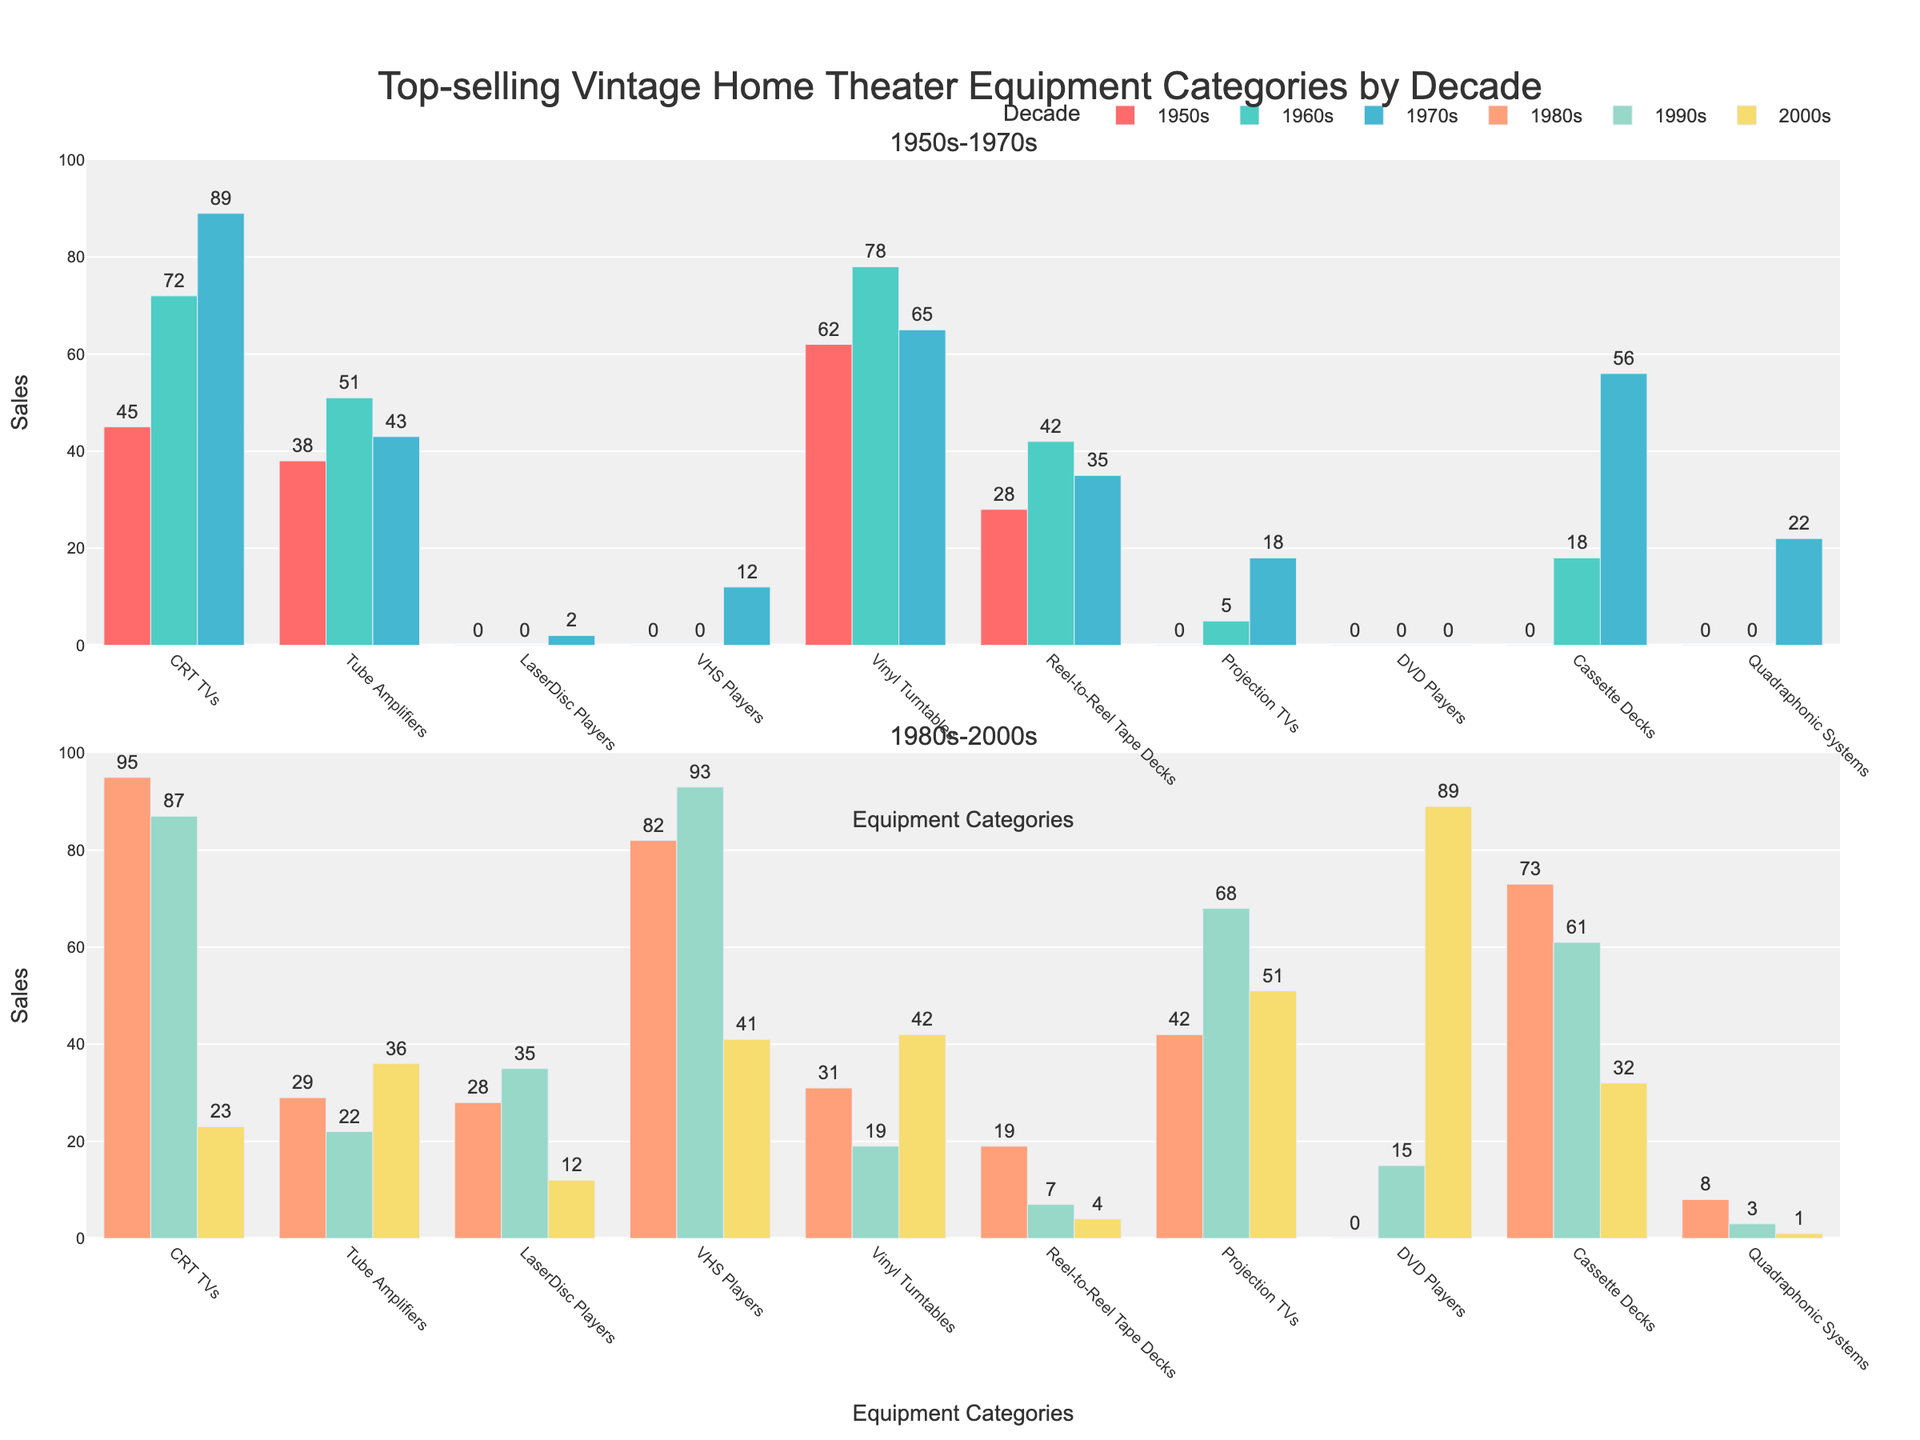What was the highest-selling equipment category in the 1980s? The highest-selling category in the 1980s can be determined by identifying the tallest bar within the 1980s group. The VHS Players bar is the tallest.
Answer: VHS Players Which decade saw the highest sales for DVD Players? The height of the DVD Players bar in each decade can reveal the highest sales. The tallest DVD Players bar appears in the 2000s section.
Answer: 2000s How did the sales of CRT TVs change from the 1950s to the 1990s? By comparing the heights of the CRT TVs bars from the 1950s to the 1990s, we observe that the heights were 45 in 1950s, 72 in 1960s, 89 in 1970s, 95 in 1980s, and 87 in 1990s.
Answer: Sales increased to a peak in the 1980s and then slightly declined in the 1990s Which decade had the most evenly distributed sales across all categories? To find the most evenly distributed sales, compare the bar heights within each decade. The 2000s decade shows more uniform heights across most categories compared to other decades.
Answer: 2000s Which two equipment categories had the highest combined sales in the 1970s? To find the top two categories in the 1970s, we look at the bars for that decade. The highest two bars are CRT TVs with 89 and Vinyl Turntables with 65. Summing them up gives 154.
Answer: CRT TVs and Vinyl Turntables What is the difference in sales between LaserDisc Players and VHS Players in the 1980s? From the 1980s bar heights, LaserDisc Players have 28 and VHS Players have 82. The difference is 82 - 28 = 54.
Answer: 54 Which category showed a significant increase in sales in the 2000s compared to the 1990s? Comparing the 2000s and 1990s bars side-by-side reveals that DVD Players sales increased significantly from 15 in the 1990s to 89 in the 2000s.
Answer: DVD Players How do the sales of Reel-to-Reel Tape Decks compare between the 1960s and 1980s? In the 1960s, Reel-to-Reel Tape Decks show a bar height of 42, while in the 1980s, the height is 19. Hence, sales decreased by 42 - 19 = 23.
Answer: Decreased by 23 What are the combined sales of Tube Amplifiers in the 1950s and 1960s? Sum the Tube Amplifiers sales from the 1950s and 1960s bars. In the 1950s, it is 38, and in the 1960s, it is 51. The combined sales are 38 + 51 = 89.
Answer: 89 